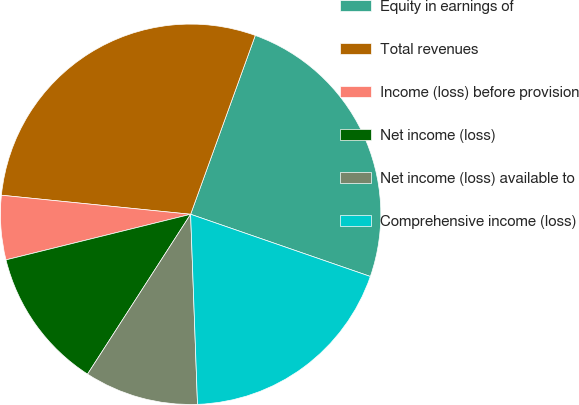<chart> <loc_0><loc_0><loc_500><loc_500><pie_chart><fcel>Equity in earnings of<fcel>Total revenues<fcel>Income (loss) before provision<fcel>Net income (loss)<fcel>Net income (loss) available to<fcel>Comprehensive income (loss)<nl><fcel>24.78%<fcel>28.92%<fcel>5.45%<fcel>12.03%<fcel>9.69%<fcel>19.12%<nl></chart> 